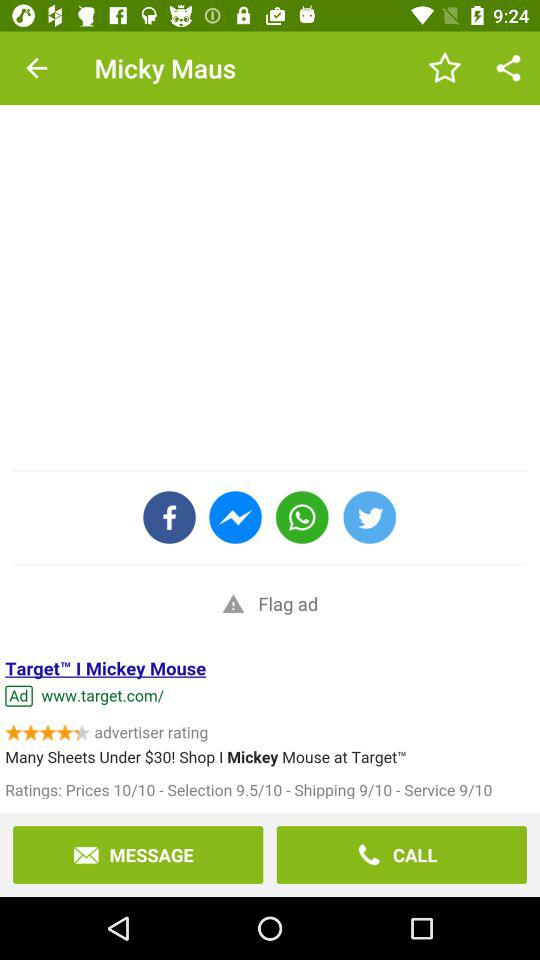How many sheets are under $30? There are many sheets under $30. 